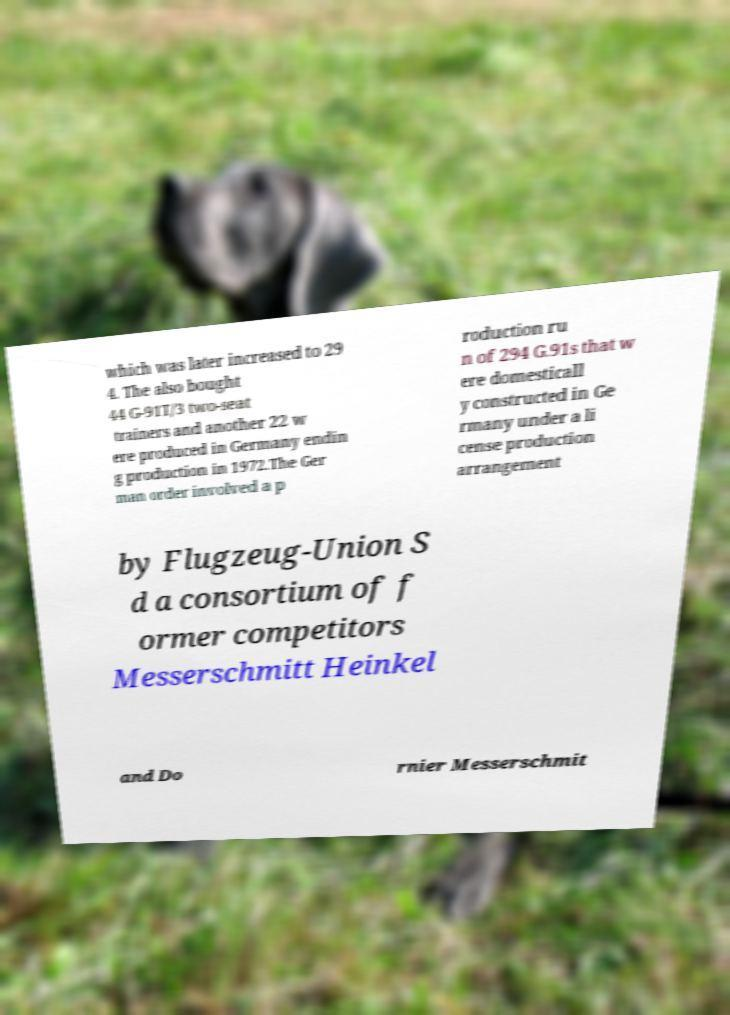Can you accurately transcribe the text from the provided image for me? which was later increased to 29 4. The also bought 44 G-91T/3 two-seat trainers and another 22 w ere produced in Germany endin g production in 1972.The Ger man order involved a p roduction ru n of 294 G.91s that w ere domesticall y constructed in Ge rmany under a li cense production arrangement by Flugzeug-Union S d a consortium of f ormer competitors Messerschmitt Heinkel and Do rnier Messerschmit 